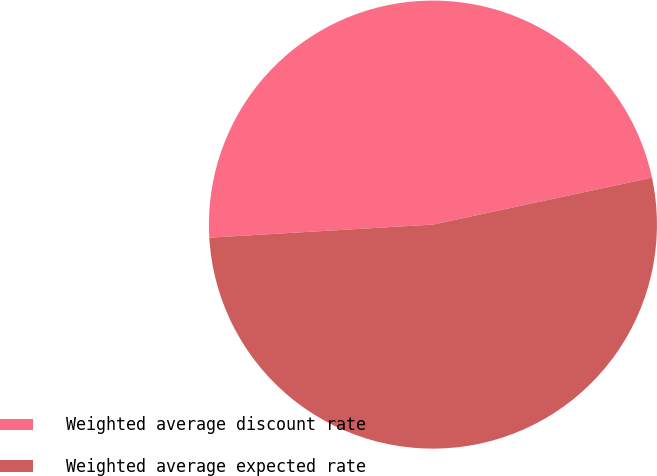<chart> <loc_0><loc_0><loc_500><loc_500><pie_chart><fcel>Weighted average discount rate<fcel>Weighted average expected rate<nl><fcel>47.57%<fcel>52.43%<nl></chart> 